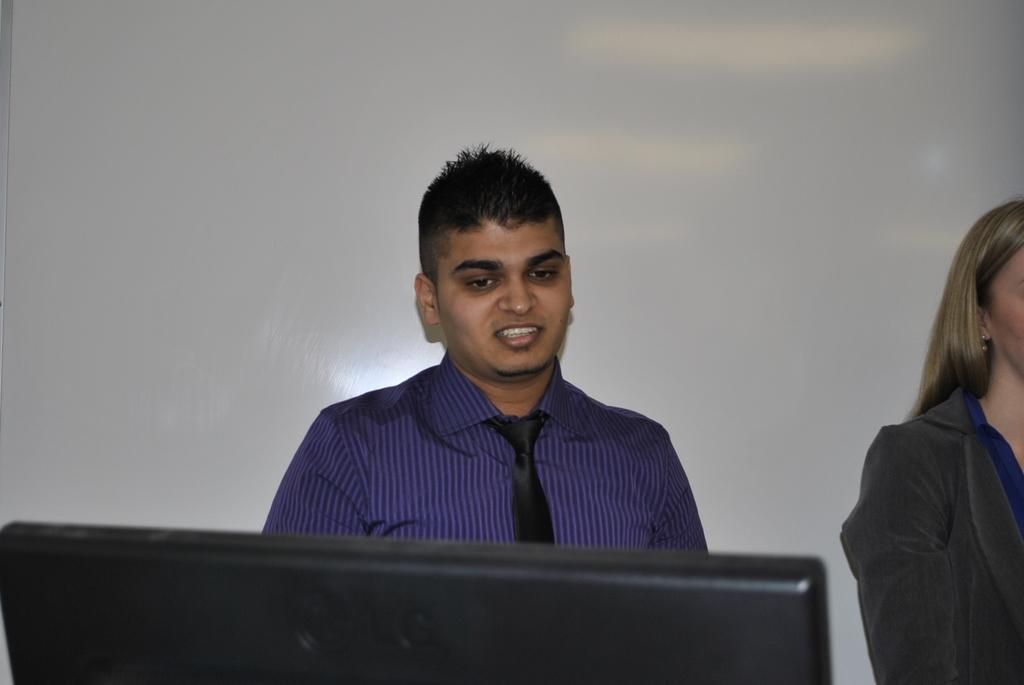Describe this image in one or two sentences. In this picture we can see there are two people on the path and in front of the man it is looking like a black monitor. Behind the people there is a white wall. 